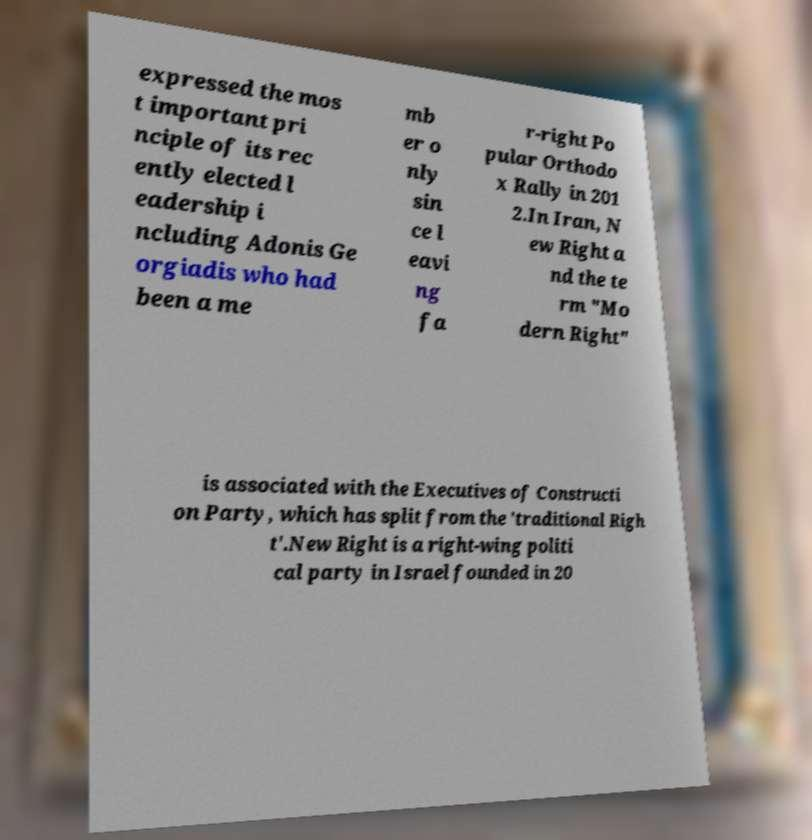I need the written content from this picture converted into text. Can you do that? expressed the mos t important pri nciple of its rec ently elected l eadership i ncluding Adonis Ge orgiadis who had been a me mb er o nly sin ce l eavi ng fa r-right Po pular Orthodo x Rally in 201 2.In Iran, N ew Right a nd the te rm "Mo dern Right" is associated with the Executives of Constructi on Party, which has split from the 'traditional Righ t'.New Right is a right-wing politi cal party in Israel founded in 20 